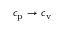Convert formula to latex. <formula><loc_0><loc_0><loc_500><loc_500>c _ { p } \rightarrow c _ { v }</formula> 